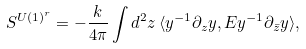Convert formula to latex. <formula><loc_0><loc_0><loc_500><loc_500>S ^ { U ( 1 ) ^ { r } } = - \frac { k } { 4 \pi } \int d ^ { 2 } z \, \langle y ^ { - 1 } \partial _ { z } y , E y ^ { - 1 } \partial _ { \bar { z } } y \rangle ,</formula> 